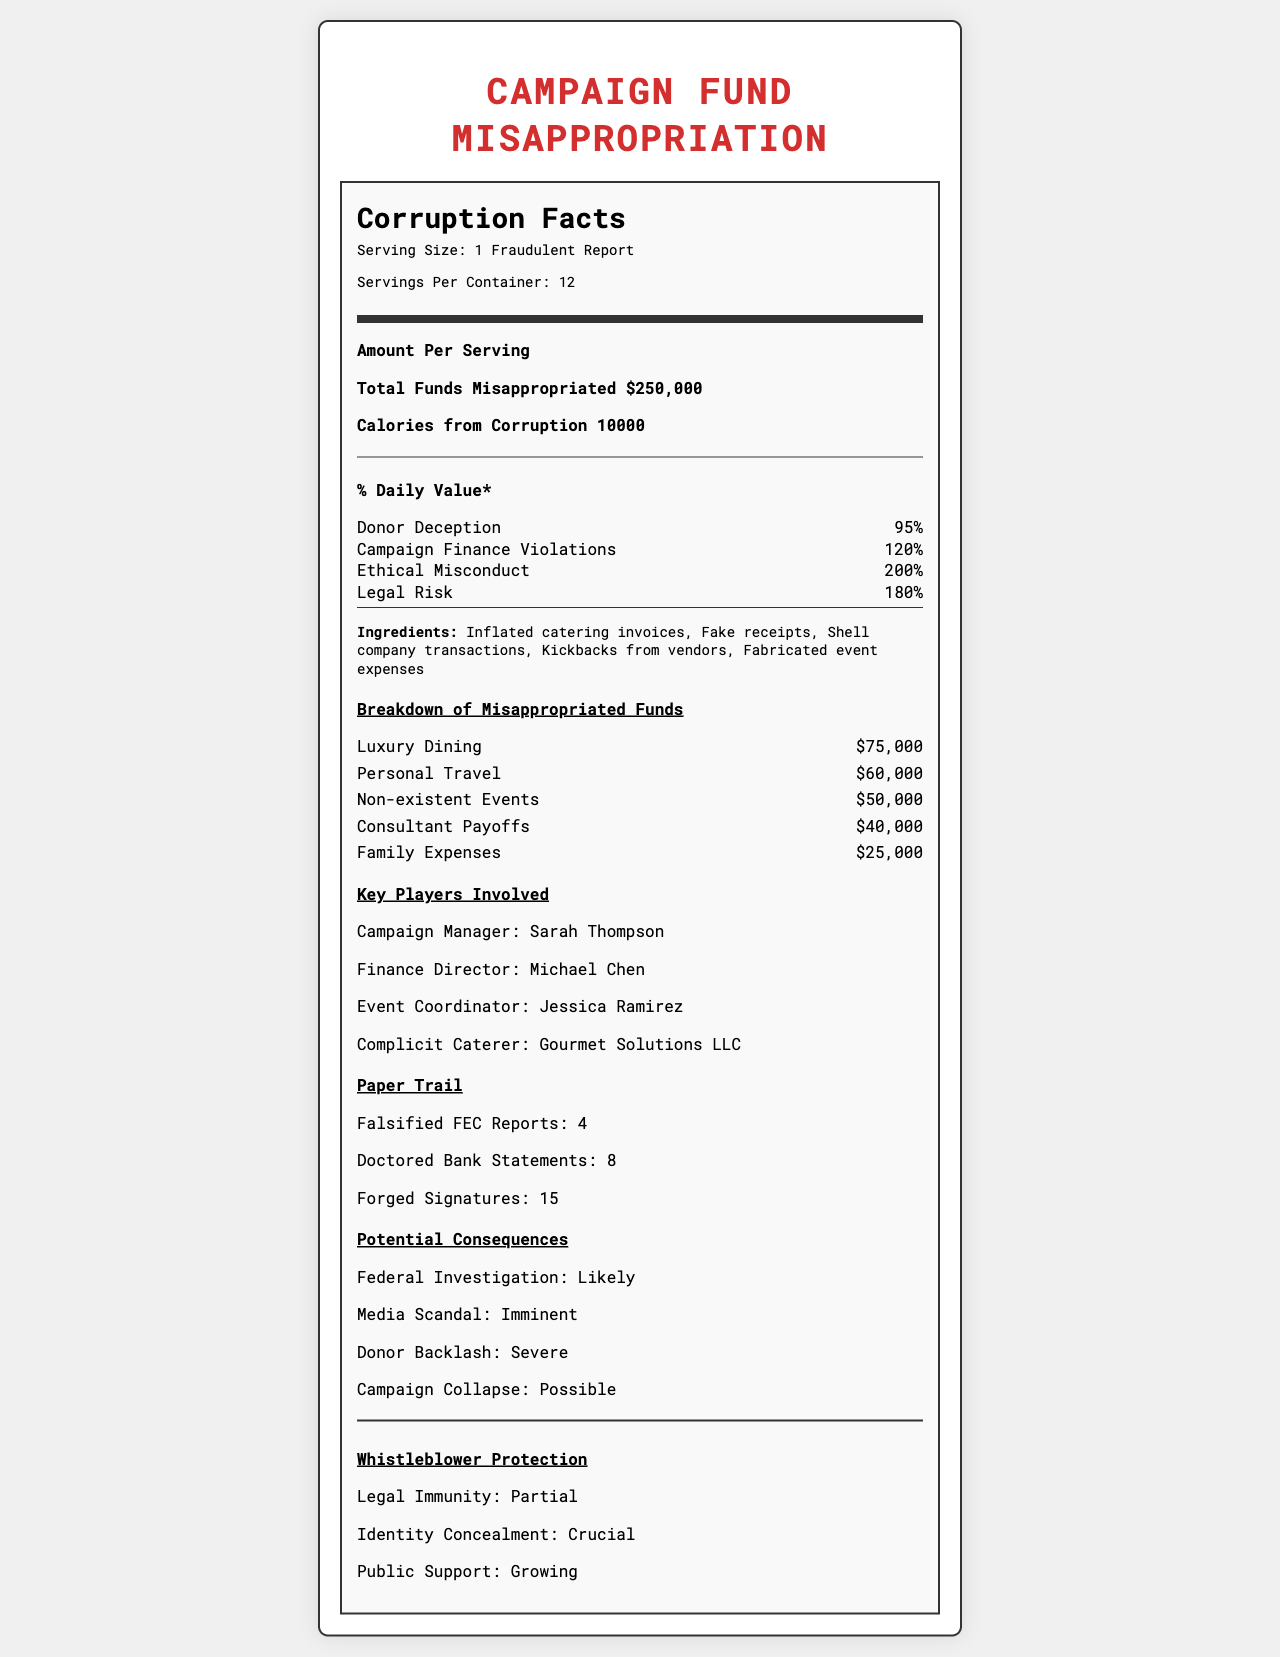what is the serving size? The serving size is listed in the document under the header "Serving Size."
Answer: 1 Fraudulent Report Who is the Finance Director involved in the misappropriations? Michael Chen is listed as the Finance Director under the section "Key Players Involved."
Answer: Michael Chen How much money was misappropriated for Personal Travel? The breakdown of misappropriated funds lists Personal Travel with an amount of $60,000.
Answer: $60,000 What percentage of daily value does Ethical Misconduct contribute? Under the "% Daily Value*" section, Ethical Misconduct is listed as contributing 200%.
Answer: 200% Name one ingredient listed in the document. Under the "Ingredients" section, one of the listed items is "Inflated catering invoices."
Answer: Inflated catering invoices Which of the following is a potential consequence of the fund misappropriation? A. Increase in Campaign Revenue B. Federal Investigation C. Improved Public Image Under "Potential Consequences," Federal Investigation is listed as a likely consequence.
Answer: B What is the total amount allocated to Luxury Dining in the misappropriation? A: $75,000 B. $60,000 C. $50,000 D. $40,000 The breakdown of misappropriated funds lists Luxury Dining with an amount of $75,000.
Answer: A Is Gourmet Solutions LLC listed as a key player involved in the document? Under "Key Players Involved," Gourmet Solutions LLC is listed as the Complicit Caterer.
Answer: Yes Summarize the main idea of this document. The document uses the format of a Nutrition Facts Label to explain in detail how campaign funds were misappropriated, including who was involved, the types of fraudulent expenses, and the risks and consequences associated with the misappropriation.
Answer: This document is styled like a Nutrition Facts Label and details the misappropriation of campaign funds disguised as "catering expenses." It provides information about the amount of funds misappropriated, the key players involved, the breakdown of misappropriated funds, the paper trail, potential consequences, and whistleblower protection measures. What was the total number of doctored bank statements? The number of doctored bank statements is listed as 8 under the "Paper Trail" section.
Answer: 8 Which of the following actions has the highest risk value? A. Donor Deception B. Campaign Finance Violations C. Legal Risk D. Ethical Misconduct The "Ethical Misconduct" is listed with a daily value of 200%, which is the highest among the options given.
Answer: D What was the total amount allocated to non-existent events? The breakdown of misappropriated funds lists Non-existent Events with an amount of $50,000.
Answer: $50,000 How many falsified FEC reports are listed in the document? The "Paper Trail" section lists 4 falsified FEC reports.
Answer: 4 What is the potential consequence of a media scandal according to the document? The "Potential Consequences" section lists a media scandal as "Imminent."
Answer: Imminent Which key player has the main responsibility for coordinating events? Under the "Key Players Involved" section, Jessica Ramirez is listed as the Event Coordinator.
Answer: Jessica Ramirez How many forged signatures are documented? The "Paper Trail" section lists 15 forged signatures.
Answer: 15 How much money was given as payoffs to consultants in the misappropriation? The "Breakdown of Misappropriated Funds" lists $40,000 for Consultant Payoffs.
Answer: $40,000 What are the benefits listed for whistleblower protection? The "Whistleblower Protection" section lists these benefits.
Answer: Legal Immunity, Identity Concealment, Public Support What kinds of documents were falsified according to the document? The "Paper Trail" sections lists falsified FEC reports, doctored bank statements, and forged signatures.
Answer: FEC reports, bank statements, signatures Who is the campaign manager responsible for the misappropriation? The "Key Players Involved" section lists Sarah Thompson as the Campaign Manager.
Answer: Sarah Thompson Based on the document, how were funds misappropriated as catering expenses? The document lists the ingredients used to disguise the funds but does not provide details on the specific methods used to execute these actions.
Answer: Cannot be determined 